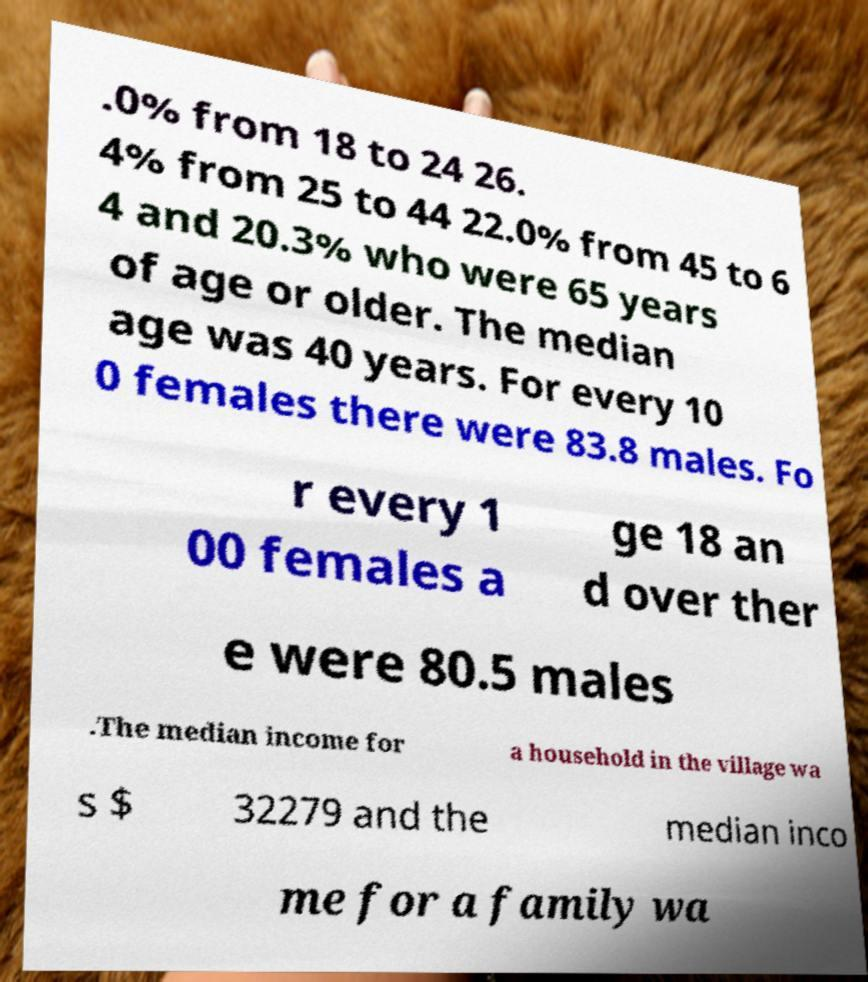For documentation purposes, I need the text within this image transcribed. Could you provide that? .0% from 18 to 24 26. 4% from 25 to 44 22.0% from 45 to 6 4 and 20.3% who were 65 years of age or older. The median age was 40 years. For every 10 0 females there were 83.8 males. Fo r every 1 00 females a ge 18 an d over ther e were 80.5 males .The median income for a household in the village wa s $ 32279 and the median inco me for a family wa 